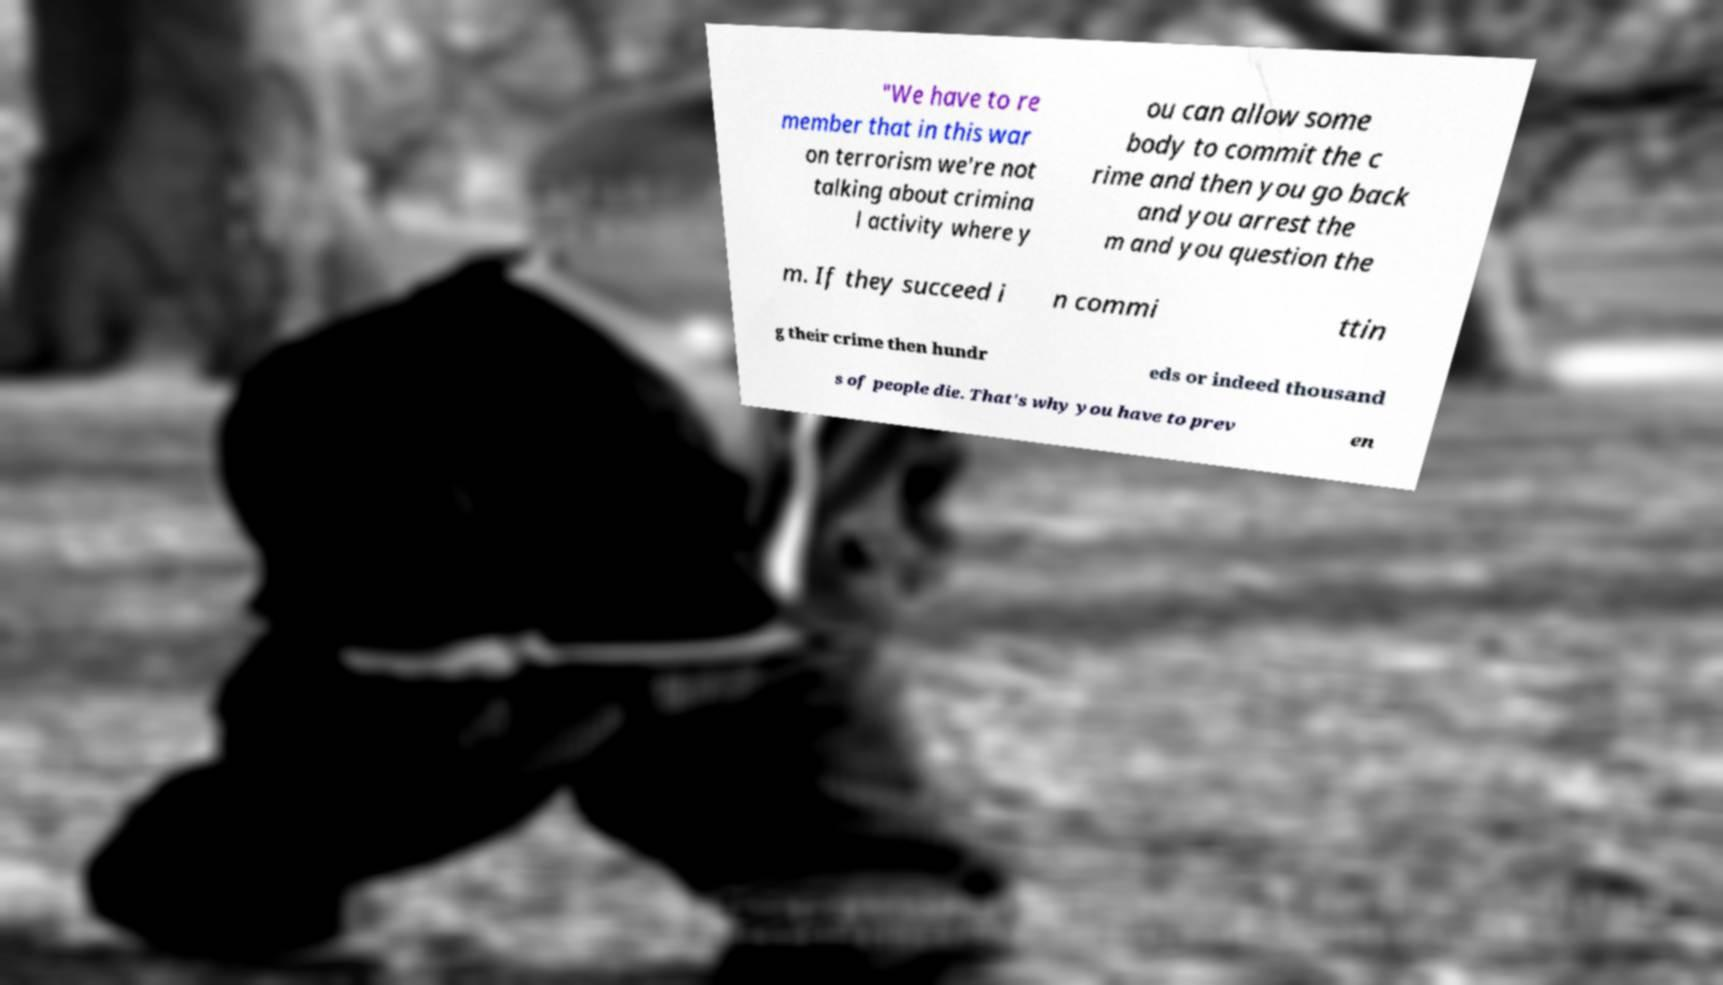Could you assist in decoding the text presented in this image and type it out clearly? "We have to re member that in this war on terrorism we're not talking about crimina l activity where y ou can allow some body to commit the c rime and then you go back and you arrest the m and you question the m. If they succeed i n commi ttin g their crime then hundr eds or indeed thousand s of people die. That's why you have to prev en 